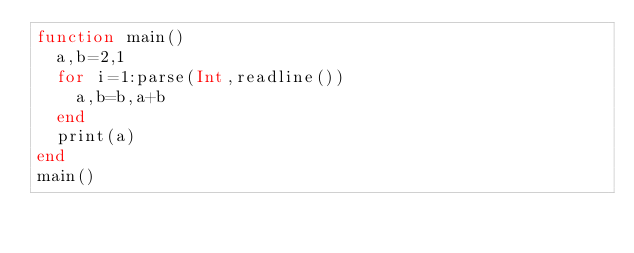Convert code to text. <code><loc_0><loc_0><loc_500><loc_500><_Julia_>function main()
	a,b=2,1
	for i=1:parse(Int,readline())
		a,b=b,a+b
	end
	print(a)
end
main()</code> 